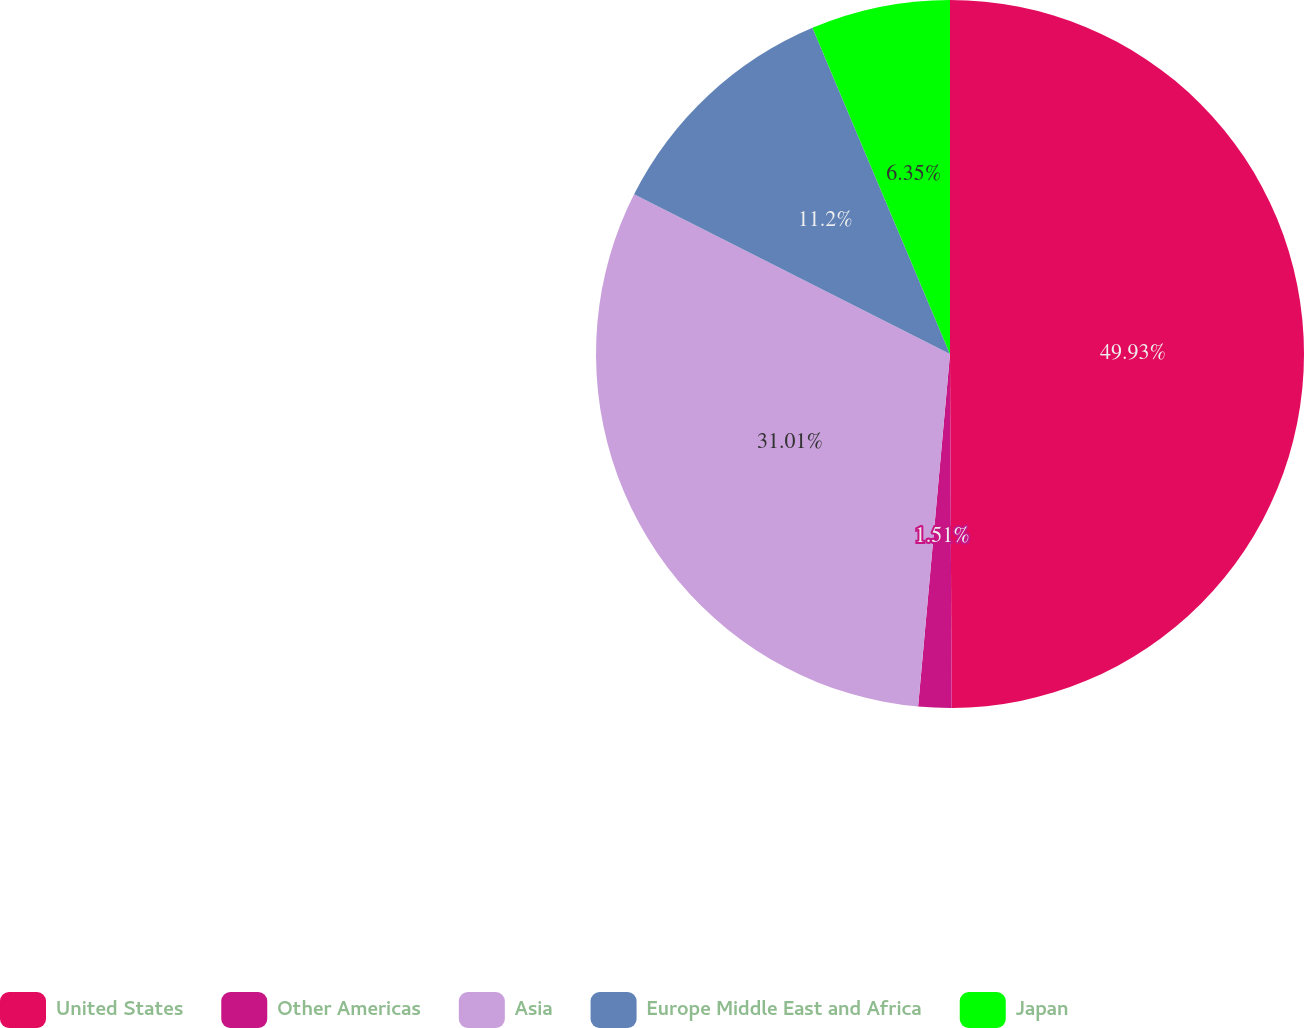Convert chart to OTSL. <chart><loc_0><loc_0><loc_500><loc_500><pie_chart><fcel>United States<fcel>Other Americas<fcel>Asia<fcel>Europe Middle East and Africa<fcel>Japan<nl><fcel>49.92%<fcel>1.51%<fcel>31.01%<fcel>11.2%<fcel>6.35%<nl></chart> 